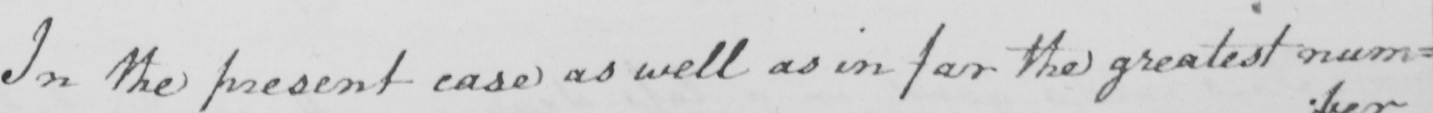Can you read and transcribe this handwriting? In the present case as well as in far the greatest num= 